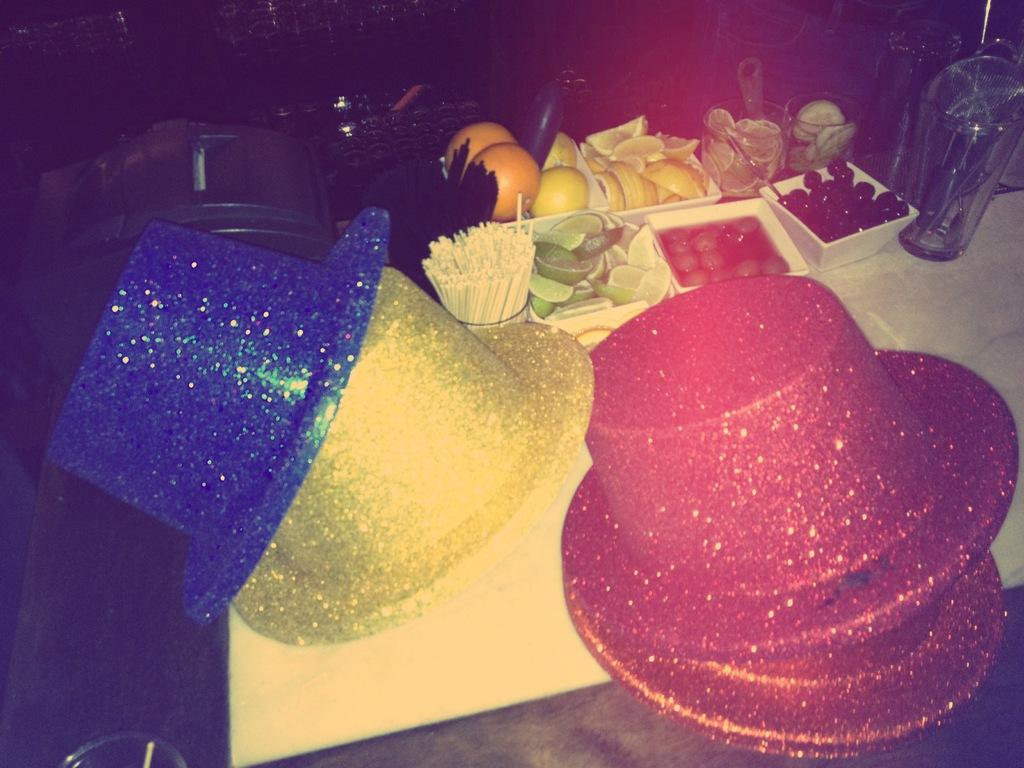What type of accessory is present in the image? There are hats in the image. Can you describe the hats in the image? The hats are in different colors. What else can be seen in the image besides the hats? There are eatables and other objects in the image. What type of crime is being committed in the image? There is no indication of a crime being committed in the image; it features hats in different colors, eatables, and other objects. How does the hydrant contribute to the scene in the image? There is no hydrant present in the image. 